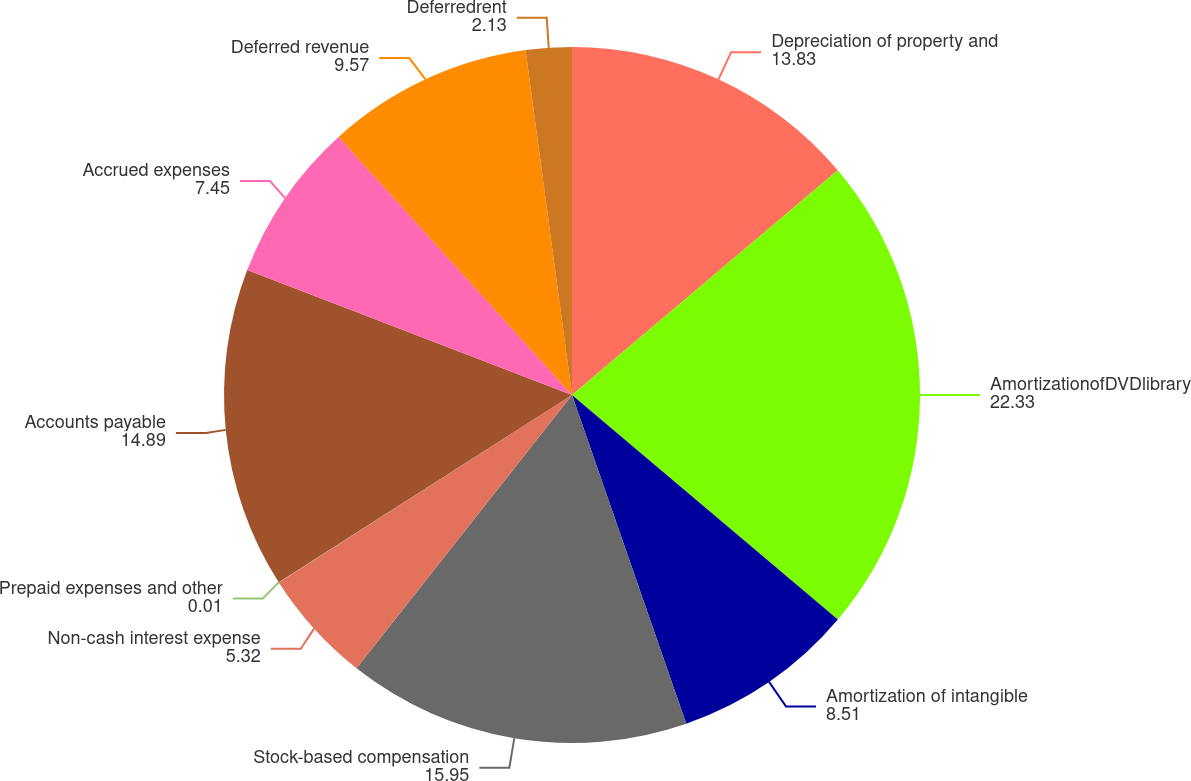<chart> <loc_0><loc_0><loc_500><loc_500><pie_chart><fcel>Depreciation of property and<fcel>AmortizationofDVDlibrary<fcel>Amortization of intangible<fcel>Stock-based compensation<fcel>Non-cash interest expense<fcel>Prepaid expenses and other<fcel>Accounts payable<fcel>Accrued expenses<fcel>Deferred revenue<fcel>Deferredrent<nl><fcel>13.83%<fcel>22.33%<fcel>8.51%<fcel>15.95%<fcel>5.32%<fcel>0.01%<fcel>14.89%<fcel>7.45%<fcel>9.57%<fcel>2.13%<nl></chart> 